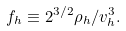Convert formula to latex. <formula><loc_0><loc_0><loc_500><loc_500>f _ { h } \equiv 2 ^ { 3 / 2 } \rho _ { h } / v _ { h } ^ { 3 } .</formula> 